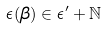Convert formula to latex. <formula><loc_0><loc_0><loc_500><loc_500>\epsilon ( \beta ) \in \epsilon ^ { \prime } + \mathbb { N }</formula> 